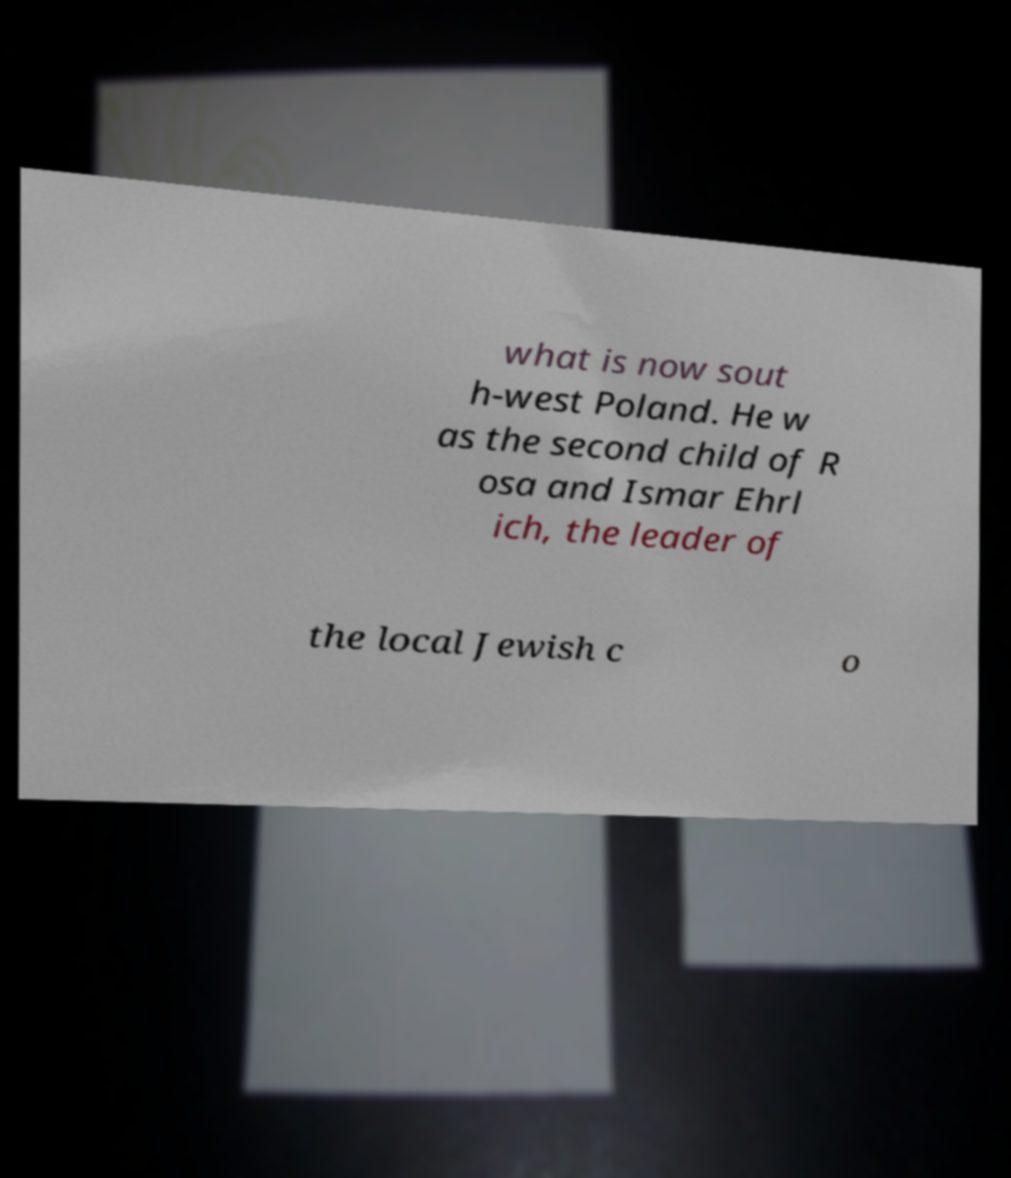Can you read and provide the text displayed in the image?This photo seems to have some interesting text. Can you extract and type it out for me? what is now sout h-west Poland. He w as the second child of R osa and Ismar Ehrl ich, the leader of the local Jewish c o 